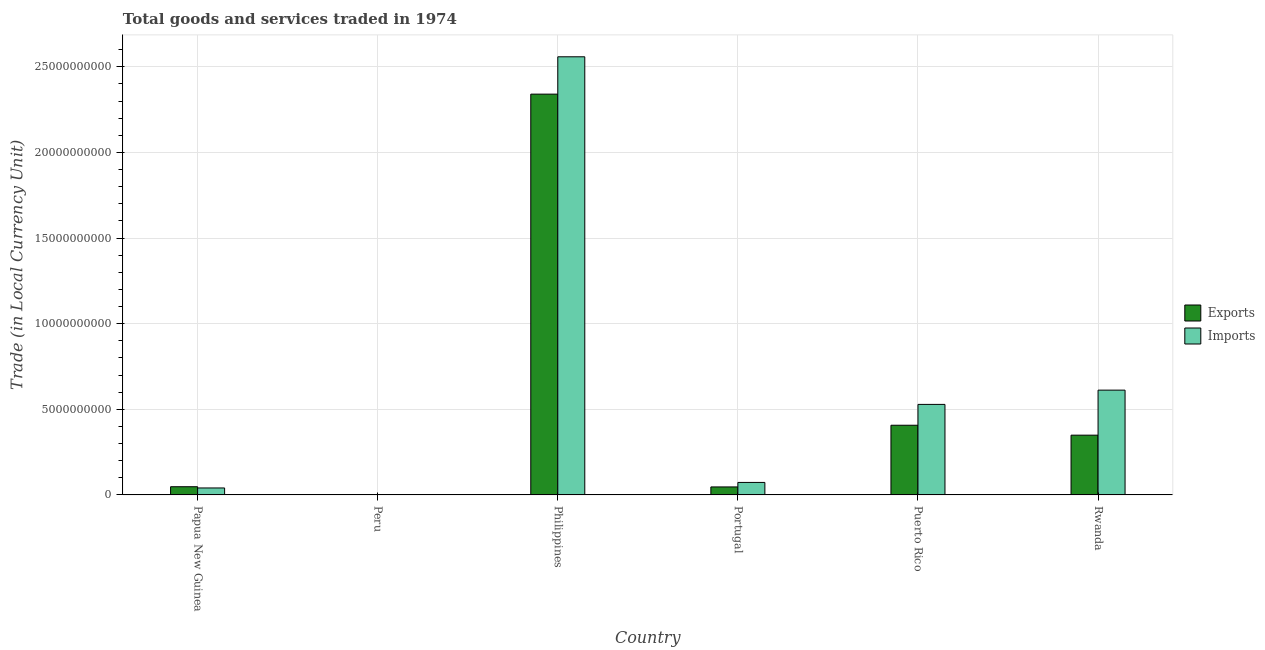How many different coloured bars are there?
Offer a terse response. 2. How many groups of bars are there?
Your answer should be very brief. 6. Are the number of bars per tick equal to the number of legend labels?
Your answer should be compact. Yes. Are the number of bars on each tick of the X-axis equal?
Provide a short and direct response. Yes. How many bars are there on the 6th tick from the left?
Provide a succinct answer. 2. What is the export of goods and services in Peru?
Give a very brief answer. 75.7. Across all countries, what is the maximum export of goods and services?
Provide a succinct answer. 2.34e+1. Across all countries, what is the minimum imports of goods and services?
Provide a short and direct response. 114.5. What is the total imports of goods and services in the graph?
Provide a succinct answer. 3.81e+1. What is the difference between the imports of goods and services in Puerto Rico and that in Rwanda?
Your answer should be compact. -8.33e+08. What is the difference between the imports of goods and services in Portugal and the export of goods and services in Peru?
Provide a succinct answer. 7.30e+08. What is the average imports of goods and services per country?
Provide a short and direct response. 6.36e+09. What is the difference between the export of goods and services and imports of goods and services in Peru?
Make the answer very short. -38.8. In how many countries, is the imports of goods and services greater than 5000000000 LCU?
Your answer should be very brief. 3. What is the ratio of the export of goods and services in Papua New Guinea to that in Portugal?
Your response must be concise. 1.03. What is the difference between the highest and the second highest export of goods and services?
Keep it short and to the point. 1.93e+1. What is the difference between the highest and the lowest imports of goods and services?
Your answer should be compact. 2.56e+1. What does the 1st bar from the left in Portugal represents?
Offer a terse response. Exports. What does the 1st bar from the right in Papua New Guinea represents?
Provide a succinct answer. Imports. How many bars are there?
Offer a terse response. 12. What is the difference between two consecutive major ticks on the Y-axis?
Offer a terse response. 5.00e+09. Does the graph contain any zero values?
Your response must be concise. No. Does the graph contain grids?
Your answer should be compact. Yes. Where does the legend appear in the graph?
Offer a terse response. Center right. How are the legend labels stacked?
Offer a very short reply. Vertical. What is the title of the graph?
Ensure brevity in your answer.  Total goods and services traded in 1974. What is the label or title of the X-axis?
Offer a terse response. Country. What is the label or title of the Y-axis?
Your response must be concise. Trade (in Local Currency Unit). What is the Trade (in Local Currency Unit) in Exports in Papua New Guinea?
Your answer should be compact. 4.79e+08. What is the Trade (in Local Currency Unit) in Imports in Papua New Guinea?
Offer a very short reply. 4.07e+08. What is the Trade (in Local Currency Unit) of Exports in Peru?
Provide a succinct answer. 75.7. What is the Trade (in Local Currency Unit) of Imports in Peru?
Ensure brevity in your answer.  114.5. What is the Trade (in Local Currency Unit) in Exports in Philippines?
Provide a succinct answer. 2.34e+1. What is the Trade (in Local Currency Unit) of Imports in Philippines?
Keep it short and to the point. 2.56e+1. What is the Trade (in Local Currency Unit) of Exports in Portugal?
Your answer should be compact. 4.67e+08. What is the Trade (in Local Currency Unit) in Imports in Portugal?
Give a very brief answer. 7.30e+08. What is the Trade (in Local Currency Unit) in Exports in Puerto Rico?
Provide a succinct answer. 4.07e+09. What is the Trade (in Local Currency Unit) in Imports in Puerto Rico?
Give a very brief answer. 5.29e+09. What is the Trade (in Local Currency Unit) of Exports in Rwanda?
Your answer should be compact. 3.49e+09. What is the Trade (in Local Currency Unit) in Imports in Rwanda?
Your answer should be very brief. 6.12e+09. Across all countries, what is the maximum Trade (in Local Currency Unit) of Exports?
Your response must be concise. 2.34e+1. Across all countries, what is the maximum Trade (in Local Currency Unit) of Imports?
Provide a succinct answer. 2.56e+1. Across all countries, what is the minimum Trade (in Local Currency Unit) in Exports?
Your answer should be compact. 75.7. Across all countries, what is the minimum Trade (in Local Currency Unit) of Imports?
Your response must be concise. 114.5. What is the total Trade (in Local Currency Unit) of Exports in the graph?
Make the answer very short. 3.19e+1. What is the total Trade (in Local Currency Unit) of Imports in the graph?
Offer a very short reply. 3.81e+1. What is the difference between the Trade (in Local Currency Unit) of Exports in Papua New Guinea and that in Peru?
Offer a terse response. 4.79e+08. What is the difference between the Trade (in Local Currency Unit) in Imports in Papua New Guinea and that in Peru?
Provide a succinct answer. 4.07e+08. What is the difference between the Trade (in Local Currency Unit) of Exports in Papua New Guinea and that in Philippines?
Offer a terse response. -2.29e+1. What is the difference between the Trade (in Local Currency Unit) of Imports in Papua New Guinea and that in Philippines?
Provide a short and direct response. -2.52e+1. What is the difference between the Trade (in Local Currency Unit) in Exports in Papua New Guinea and that in Portugal?
Give a very brief answer. 1.22e+07. What is the difference between the Trade (in Local Currency Unit) of Imports in Papua New Guinea and that in Portugal?
Make the answer very short. -3.22e+08. What is the difference between the Trade (in Local Currency Unit) of Exports in Papua New Guinea and that in Puerto Rico?
Your answer should be compact. -3.59e+09. What is the difference between the Trade (in Local Currency Unit) of Imports in Papua New Guinea and that in Puerto Rico?
Your response must be concise. -4.88e+09. What is the difference between the Trade (in Local Currency Unit) of Exports in Papua New Guinea and that in Rwanda?
Offer a very short reply. -3.01e+09. What is the difference between the Trade (in Local Currency Unit) in Imports in Papua New Guinea and that in Rwanda?
Your response must be concise. -5.71e+09. What is the difference between the Trade (in Local Currency Unit) of Exports in Peru and that in Philippines?
Provide a succinct answer. -2.34e+1. What is the difference between the Trade (in Local Currency Unit) of Imports in Peru and that in Philippines?
Provide a short and direct response. -2.56e+1. What is the difference between the Trade (in Local Currency Unit) in Exports in Peru and that in Portugal?
Your answer should be very brief. -4.67e+08. What is the difference between the Trade (in Local Currency Unit) of Imports in Peru and that in Portugal?
Keep it short and to the point. -7.30e+08. What is the difference between the Trade (in Local Currency Unit) in Exports in Peru and that in Puerto Rico?
Provide a succinct answer. -4.07e+09. What is the difference between the Trade (in Local Currency Unit) in Imports in Peru and that in Puerto Rico?
Offer a terse response. -5.29e+09. What is the difference between the Trade (in Local Currency Unit) of Exports in Peru and that in Rwanda?
Your answer should be compact. -3.49e+09. What is the difference between the Trade (in Local Currency Unit) in Imports in Peru and that in Rwanda?
Provide a short and direct response. -6.12e+09. What is the difference between the Trade (in Local Currency Unit) in Exports in Philippines and that in Portugal?
Your answer should be compact. 2.29e+1. What is the difference between the Trade (in Local Currency Unit) of Imports in Philippines and that in Portugal?
Provide a short and direct response. 2.49e+1. What is the difference between the Trade (in Local Currency Unit) in Exports in Philippines and that in Puerto Rico?
Keep it short and to the point. 1.93e+1. What is the difference between the Trade (in Local Currency Unit) in Imports in Philippines and that in Puerto Rico?
Your response must be concise. 2.03e+1. What is the difference between the Trade (in Local Currency Unit) in Exports in Philippines and that in Rwanda?
Provide a succinct answer. 1.99e+1. What is the difference between the Trade (in Local Currency Unit) of Imports in Philippines and that in Rwanda?
Keep it short and to the point. 1.95e+1. What is the difference between the Trade (in Local Currency Unit) in Exports in Portugal and that in Puerto Rico?
Provide a short and direct response. -3.60e+09. What is the difference between the Trade (in Local Currency Unit) of Imports in Portugal and that in Puerto Rico?
Your response must be concise. -4.56e+09. What is the difference between the Trade (in Local Currency Unit) in Exports in Portugal and that in Rwanda?
Provide a short and direct response. -3.02e+09. What is the difference between the Trade (in Local Currency Unit) in Imports in Portugal and that in Rwanda?
Offer a very short reply. -5.39e+09. What is the difference between the Trade (in Local Currency Unit) in Exports in Puerto Rico and that in Rwanda?
Offer a terse response. 5.80e+08. What is the difference between the Trade (in Local Currency Unit) in Imports in Puerto Rico and that in Rwanda?
Your response must be concise. -8.33e+08. What is the difference between the Trade (in Local Currency Unit) in Exports in Papua New Guinea and the Trade (in Local Currency Unit) in Imports in Peru?
Offer a very short reply. 4.79e+08. What is the difference between the Trade (in Local Currency Unit) in Exports in Papua New Guinea and the Trade (in Local Currency Unit) in Imports in Philippines?
Ensure brevity in your answer.  -2.51e+1. What is the difference between the Trade (in Local Currency Unit) in Exports in Papua New Guinea and the Trade (in Local Currency Unit) in Imports in Portugal?
Provide a short and direct response. -2.50e+08. What is the difference between the Trade (in Local Currency Unit) of Exports in Papua New Guinea and the Trade (in Local Currency Unit) of Imports in Puerto Rico?
Ensure brevity in your answer.  -4.81e+09. What is the difference between the Trade (in Local Currency Unit) of Exports in Papua New Guinea and the Trade (in Local Currency Unit) of Imports in Rwanda?
Ensure brevity in your answer.  -5.64e+09. What is the difference between the Trade (in Local Currency Unit) of Exports in Peru and the Trade (in Local Currency Unit) of Imports in Philippines?
Ensure brevity in your answer.  -2.56e+1. What is the difference between the Trade (in Local Currency Unit) of Exports in Peru and the Trade (in Local Currency Unit) of Imports in Portugal?
Make the answer very short. -7.30e+08. What is the difference between the Trade (in Local Currency Unit) of Exports in Peru and the Trade (in Local Currency Unit) of Imports in Puerto Rico?
Provide a short and direct response. -5.29e+09. What is the difference between the Trade (in Local Currency Unit) of Exports in Peru and the Trade (in Local Currency Unit) of Imports in Rwanda?
Give a very brief answer. -6.12e+09. What is the difference between the Trade (in Local Currency Unit) of Exports in Philippines and the Trade (in Local Currency Unit) of Imports in Portugal?
Ensure brevity in your answer.  2.27e+1. What is the difference between the Trade (in Local Currency Unit) in Exports in Philippines and the Trade (in Local Currency Unit) in Imports in Puerto Rico?
Offer a terse response. 1.81e+1. What is the difference between the Trade (in Local Currency Unit) in Exports in Philippines and the Trade (in Local Currency Unit) in Imports in Rwanda?
Your response must be concise. 1.73e+1. What is the difference between the Trade (in Local Currency Unit) in Exports in Portugal and the Trade (in Local Currency Unit) in Imports in Puerto Rico?
Keep it short and to the point. -4.82e+09. What is the difference between the Trade (in Local Currency Unit) in Exports in Portugal and the Trade (in Local Currency Unit) in Imports in Rwanda?
Offer a very short reply. -5.65e+09. What is the difference between the Trade (in Local Currency Unit) in Exports in Puerto Rico and the Trade (in Local Currency Unit) in Imports in Rwanda?
Provide a short and direct response. -2.05e+09. What is the average Trade (in Local Currency Unit) of Exports per country?
Offer a very short reply. 5.32e+09. What is the average Trade (in Local Currency Unit) in Imports per country?
Offer a terse response. 6.36e+09. What is the difference between the Trade (in Local Currency Unit) of Exports and Trade (in Local Currency Unit) of Imports in Papua New Guinea?
Provide a succinct answer. 7.20e+07. What is the difference between the Trade (in Local Currency Unit) in Exports and Trade (in Local Currency Unit) in Imports in Peru?
Make the answer very short. -38.8. What is the difference between the Trade (in Local Currency Unit) in Exports and Trade (in Local Currency Unit) in Imports in Philippines?
Your answer should be very brief. -2.18e+09. What is the difference between the Trade (in Local Currency Unit) in Exports and Trade (in Local Currency Unit) in Imports in Portugal?
Provide a succinct answer. -2.63e+08. What is the difference between the Trade (in Local Currency Unit) in Exports and Trade (in Local Currency Unit) in Imports in Puerto Rico?
Provide a short and direct response. -1.22e+09. What is the difference between the Trade (in Local Currency Unit) of Exports and Trade (in Local Currency Unit) of Imports in Rwanda?
Your response must be concise. -2.63e+09. What is the ratio of the Trade (in Local Currency Unit) of Exports in Papua New Guinea to that in Peru?
Keep it short and to the point. 6.33e+06. What is the ratio of the Trade (in Local Currency Unit) of Imports in Papua New Guinea to that in Peru?
Your answer should be very brief. 3.56e+06. What is the ratio of the Trade (in Local Currency Unit) in Exports in Papua New Guinea to that in Philippines?
Make the answer very short. 0.02. What is the ratio of the Trade (in Local Currency Unit) in Imports in Papua New Guinea to that in Philippines?
Offer a terse response. 0.02. What is the ratio of the Trade (in Local Currency Unit) in Exports in Papua New Guinea to that in Portugal?
Give a very brief answer. 1.03. What is the ratio of the Trade (in Local Currency Unit) of Imports in Papua New Guinea to that in Portugal?
Ensure brevity in your answer.  0.56. What is the ratio of the Trade (in Local Currency Unit) in Exports in Papua New Guinea to that in Puerto Rico?
Your response must be concise. 0.12. What is the ratio of the Trade (in Local Currency Unit) of Imports in Papua New Guinea to that in Puerto Rico?
Your answer should be compact. 0.08. What is the ratio of the Trade (in Local Currency Unit) of Exports in Papua New Guinea to that in Rwanda?
Provide a succinct answer. 0.14. What is the ratio of the Trade (in Local Currency Unit) in Imports in Papua New Guinea to that in Rwanda?
Keep it short and to the point. 0.07. What is the ratio of the Trade (in Local Currency Unit) in Exports in Peru to that in Portugal?
Provide a short and direct response. 0. What is the ratio of the Trade (in Local Currency Unit) of Imports in Peru to that in Portugal?
Provide a succinct answer. 0. What is the ratio of the Trade (in Local Currency Unit) of Imports in Peru to that in Puerto Rico?
Offer a very short reply. 0. What is the ratio of the Trade (in Local Currency Unit) of Imports in Peru to that in Rwanda?
Provide a short and direct response. 0. What is the ratio of the Trade (in Local Currency Unit) in Exports in Philippines to that in Portugal?
Ensure brevity in your answer.  50.11. What is the ratio of the Trade (in Local Currency Unit) of Imports in Philippines to that in Portugal?
Give a very brief answer. 35.06. What is the ratio of the Trade (in Local Currency Unit) of Exports in Philippines to that in Puerto Rico?
Provide a short and direct response. 5.75. What is the ratio of the Trade (in Local Currency Unit) in Imports in Philippines to that in Puerto Rico?
Provide a succinct answer. 4.84. What is the ratio of the Trade (in Local Currency Unit) of Exports in Philippines to that in Rwanda?
Give a very brief answer. 6.71. What is the ratio of the Trade (in Local Currency Unit) of Imports in Philippines to that in Rwanda?
Your response must be concise. 4.18. What is the ratio of the Trade (in Local Currency Unit) in Exports in Portugal to that in Puerto Rico?
Your answer should be compact. 0.11. What is the ratio of the Trade (in Local Currency Unit) of Imports in Portugal to that in Puerto Rico?
Give a very brief answer. 0.14. What is the ratio of the Trade (in Local Currency Unit) in Exports in Portugal to that in Rwanda?
Your answer should be compact. 0.13. What is the ratio of the Trade (in Local Currency Unit) in Imports in Portugal to that in Rwanda?
Provide a succinct answer. 0.12. What is the ratio of the Trade (in Local Currency Unit) in Exports in Puerto Rico to that in Rwanda?
Provide a succinct answer. 1.17. What is the ratio of the Trade (in Local Currency Unit) of Imports in Puerto Rico to that in Rwanda?
Provide a succinct answer. 0.86. What is the difference between the highest and the second highest Trade (in Local Currency Unit) in Exports?
Your response must be concise. 1.93e+1. What is the difference between the highest and the second highest Trade (in Local Currency Unit) in Imports?
Make the answer very short. 1.95e+1. What is the difference between the highest and the lowest Trade (in Local Currency Unit) in Exports?
Provide a succinct answer. 2.34e+1. What is the difference between the highest and the lowest Trade (in Local Currency Unit) of Imports?
Offer a terse response. 2.56e+1. 